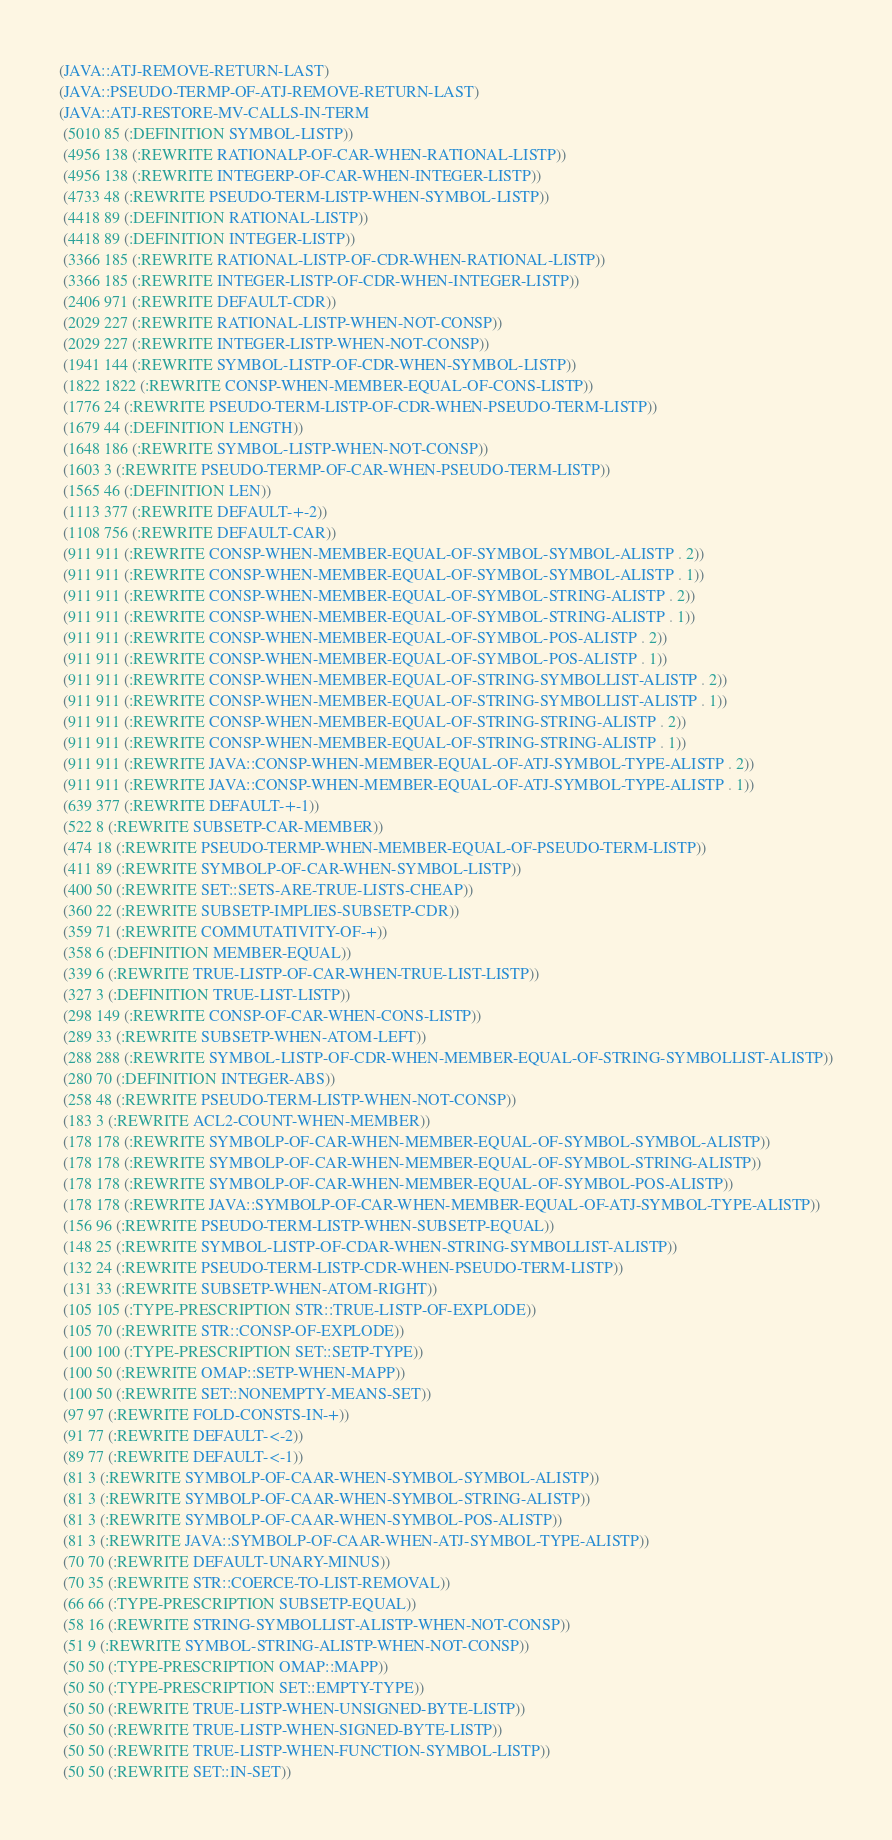<code> <loc_0><loc_0><loc_500><loc_500><_Lisp_>(JAVA::ATJ-REMOVE-RETURN-LAST)
(JAVA::PSEUDO-TERMP-OF-ATJ-REMOVE-RETURN-LAST)
(JAVA::ATJ-RESTORE-MV-CALLS-IN-TERM
 (5010 85 (:DEFINITION SYMBOL-LISTP))
 (4956 138 (:REWRITE RATIONALP-OF-CAR-WHEN-RATIONAL-LISTP))
 (4956 138 (:REWRITE INTEGERP-OF-CAR-WHEN-INTEGER-LISTP))
 (4733 48 (:REWRITE PSEUDO-TERM-LISTP-WHEN-SYMBOL-LISTP))
 (4418 89 (:DEFINITION RATIONAL-LISTP))
 (4418 89 (:DEFINITION INTEGER-LISTP))
 (3366 185 (:REWRITE RATIONAL-LISTP-OF-CDR-WHEN-RATIONAL-LISTP))
 (3366 185 (:REWRITE INTEGER-LISTP-OF-CDR-WHEN-INTEGER-LISTP))
 (2406 971 (:REWRITE DEFAULT-CDR))
 (2029 227 (:REWRITE RATIONAL-LISTP-WHEN-NOT-CONSP))
 (2029 227 (:REWRITE INTEGER-LISTP-WHEN-NOT-CONSP))
 (1941 144 (:REWRITE SYMBOL-LISTP-OF-CDR-WHEN-SYMBOL-LISTP))
 (1822 1822 (:REWRITE CONSP-WHEN-MEMBER-EQUAL-OF-CONS-LISTP))
 (1776 24 (:REWRITE PSEUDO-TERM-LISTP-OF-CDR-WHEN-PSEUDO-TERM-LISTP))
 (1679 44 (:DEFINITION LENGTH))
 (1648 186 (:REWRITE SYMBOL-LISTP-WHEN-NOT-CONSP))
 (1603 3 (:REWRITE PSEUDO-TERMP-OF-CAR-WHEN-PSEUDO-TERM-LISTP))
 (1565 46 (:DEFINITION LEN))
 (1113 377 (:REWRITE DEFAULT-+-2))
 (1108 756 (:REWRITE DEFAULT-CAR))
 (911 911 (:REWRITE CONSP-WHEN-MEMBER-EQUAL-OF-SYMBOL-SYMBOL-ALISTP . 2))
 (911 911 (:REWRITE CONSP-WHEN-MEMBER-EQUAL-OF-SYMBOL-SYMBOL-ALISTP . 1))
 (911 911 (:REWRITE CONSP-WHEN-MEMBER-EQUAL-OF-SYMBOL-STRING-ALISTP . 2))
 (911 911 (:REWRITE CONSP-WHEN-MEMBER-EQUAL-OF-SYMBOL-STRING-ALISTP . 1))
 (911 911 (:REWRITE CONSP-WHEN-MEMBER-EQUAL-OF-SYMBOL-POS-ALISTP . 2))
 (911 911 (:REWRITE CONSP-WHEN-MEMBER-EQUAL-OF-SYMBOL-POS-ALISTP . 1))
 (911 911 (:REWRITE CONSP-WHEN-MEMBER-EQUAL-OF-STRING-SYMBOLLIST-ALISTP . 2))
 (911 911 (:REWRITE CONSP-WHEN-MEMBER-EQUAL-OF-STRING-SYMBOLLIST-ALISTP . 1))
 (911 911 (:REWRITE CONSP-WHEN-MEMBER-EQUAL-OF-STRING-STRING-ALISTP . 2))
 (911 911 (:REWRITE CONSP-WHEN-MEMBER-EQUAL-OF-STRING-STRING-ALISTP . 1))
 (911 911 (:REWRITE JAVA::CONSP-WHEN-MEMBER-EQUAL-OF-ATJ-SYMBOL-TYPE-ALISTP . 2))
 (911 911 (:REWRITE JAVA::CONSP-WHEN-MEMBER-EQUAL-OF-ATJ-SYMBOL-TYPE-ALISTP . 1))
 (639 377 (:REWRITE DEFAULT-+-1))
 (522 8 (:REWRITE SUBSETP-CAR-MEMBER))
 (474 18 (:REWRITE PSEUDO-TERMP-WHEN-MEMBER-EQUAL-OF-PSEUDO-TERM-LISTP))
 (411 89 (:REWRITE SYMBOLP-OF-CAR-WHEN-SYMBOL-LISTP))
 (400 50 (:REWRITE SET::SETS-ARE-TRUE-LISTS-CHEAP))
 (360 22 (:REWRITE SUBSETP-IMPLIES-SUBSETP-CDR))
 (359 71 (:REWRITE COMMUTATIVITY-OF-+))
 (358 6 (:DEFINITION MEMBER-EQUAL))
 (339 6 (:REWRITE TRUE-LISTP-OF-CAR-WHEN-TRUE-LIST-LISTP))
 (327 3 (:DEFINITION TRUE-LIST-LISTP))
 (298 149 (:REWRITE CONSP-OF-CAR-WHEN-CONS-LISTP))
 (289 33 (:REWRITE SUBSETP-WHEN-ATOM-LEFT))
 (288 288 (:REWRITE SYMBOL-LISTP-OF-CDR-WHEN-MEMBER-EQUAL-OF-STRING-SYMBOLLIST-ALISTP))
 (280 70 (:DEFINITION INTEGER-ABS))
 (258 48 (:REWRITE PSEUDO-TERM-LISTP-WHEN-NOT-CONSP))
 (183 3 (:REWRITE ACL2-COUNT-WHEN-MEMBER))
 (178 178 (:REWRITE SYMBOLP-OF-CAR-WHEN-MEMBER-EQUAL-OF-SYMBOL-SYMBOL-ALISTP))
 (178 178 (:REWRITE SYMBOLP-OF-CAR-WHEN-MEMBER-EQUAL-OF-SYMBOL-STRING-ALISTP))
 (178 178 (:REWRITE SYMBOLP-OF-CAR-WHEN-MEMBER-EQUAL-OF-SYMBOL-POS-ALISTP))
 (178 178 (:REWRITE JAVA::SYMBOLP-OF-CAR-WHEN-MEMBER-EQUAL-OF-ATJ-SYMBOL-TYPE-ALISTP))
 (156 96 (:REWRITE PSEUDO-TERM-LISTP-WHEN-SUBSETP-EQUAL))
 (148 25 (:REWRITE SYMBOL-LISTP-OF-CDAR-WHEN-STRING-SYMBOLLIST-ALISTP))
 (132 24 (:REWRITE PSEUDO-TERM-LISTP-CDR-WHEN-PSEUDO-TERM-LISTP))
 (131 33 (:REWRITE SUBSETP-WHEN-ATOM-RIGHT))
 (105 105 (:TYPE-PRESCRIPTION STR::TRUE-LISTP-OF-EXPLODE))
 (105 70 (:REWRITE STR::CONSP-OF-EXPLODE))
 (100 100 (:TYPE-PRESCRIPTION SET::SETP-TYPE))
 (100 50 (:REWRITE OMAP::SETP-WHEN-MAPP))
 (100 50 (:REWRITE SET::NONEMPTY-MEANS-SET))
 (97 97 (:REWRITE FOLD-CONSTS-IN-+))
 (91 77 (:REWRITE DEFAULT-<-2))
 (89 77 (:REWRITE DEFAULT-<-1))
 (81 3 (:REWRITE SYMBOLP-OF-CAAR-WHEN-SYMBOL-SYMBOL-ALISTP))
 (81 3 (:REWRITE SYMBOLP-OF-CAAR-WHEN-SYMBOL-STRING-ALISTP))
 (81 3 (:REWRITE SYMBOLP-OF-CAAR-WHEN-SYMBOL-POS-ALISTP))
 (81 3 (:REWRITE JAVA::SYMBOLP-OF-CAAR-WHEN-ATJ-SYMBOL-TYPE-ALISTP))
 (70 70 (:REWRITE DEFAULT-UNARY-MINUS))
 (70 35 (:REWRITE STR::COERCE-TO-LIST-REMOVAL))
 (66 66 (:TYPE-PRESCRIPTION SUBSETP-EQUAL))
 (58 16 (:REWRITE STRING-SYMBOLLIST-ALISTP-WHEN-NOT-CONSP))
 (51 9 (:REWRITE SYMBOL-STRING-ALISTP-WHEN-NOT-CONSP))
 (50 50 (:TYPE-PRESCRIPTION OMAP::MAPP))
 (50 50 (:TYPE-PRESCRIPTION SET::EMPTY-TYPE))
 (50 50 (:REWRITE TRUE-LISTP-WHEN-UNSIGNED-BYTE-LISTP))
 (50 50 (:REWRITE TRUE-LISTP-WHEN-SIGNED-BYTE-LISTP))
 (50 50 (:REWRITE TRUE-LISTP-WHEN-FUNCTION-SYMBOL-LISTP))
 (50 50 (:REWRITE SET::IN-SET))</code> 